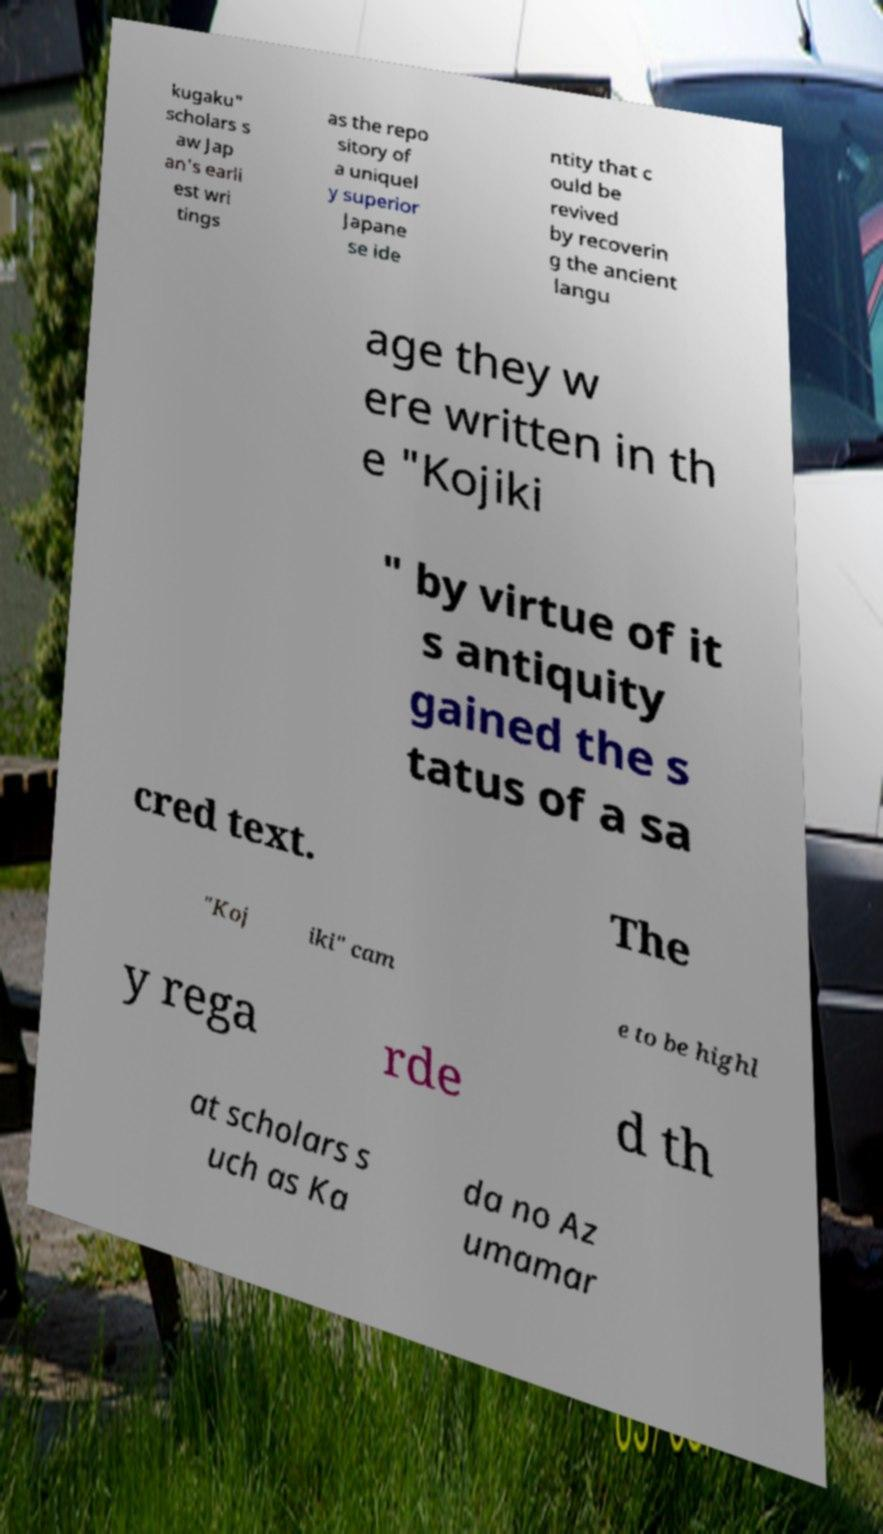For documentation purposes, I need the text within this image transcribed. Could you provide that? kugaku" scholars s aw Jap an's earli est wri tings as the repo sitory of a uniquel y superior Japane se ide ntity that c ould be revived by recoverin g the ancient langu age they w ere written in th e "Kojiki " by virtue of it s antiquity gained the s tatus of a sa cred text. The "Koj iki" cam e to be highl y rega rde d th at scholars s uch as Ka da no Az umamar 